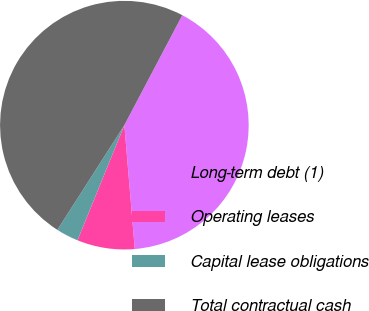<chart> <loc_0><loc_0><loc_500><loc_500><pie_chart><fcel>Long-term debt (1)<fcel>Operating leases<fcel>Capital lease obligations<fcel>Total contractual cash<nl><fcel>40.95%<fcel>7.48%<fcel>2.91%<fcel>48.66%<nl></chart> 